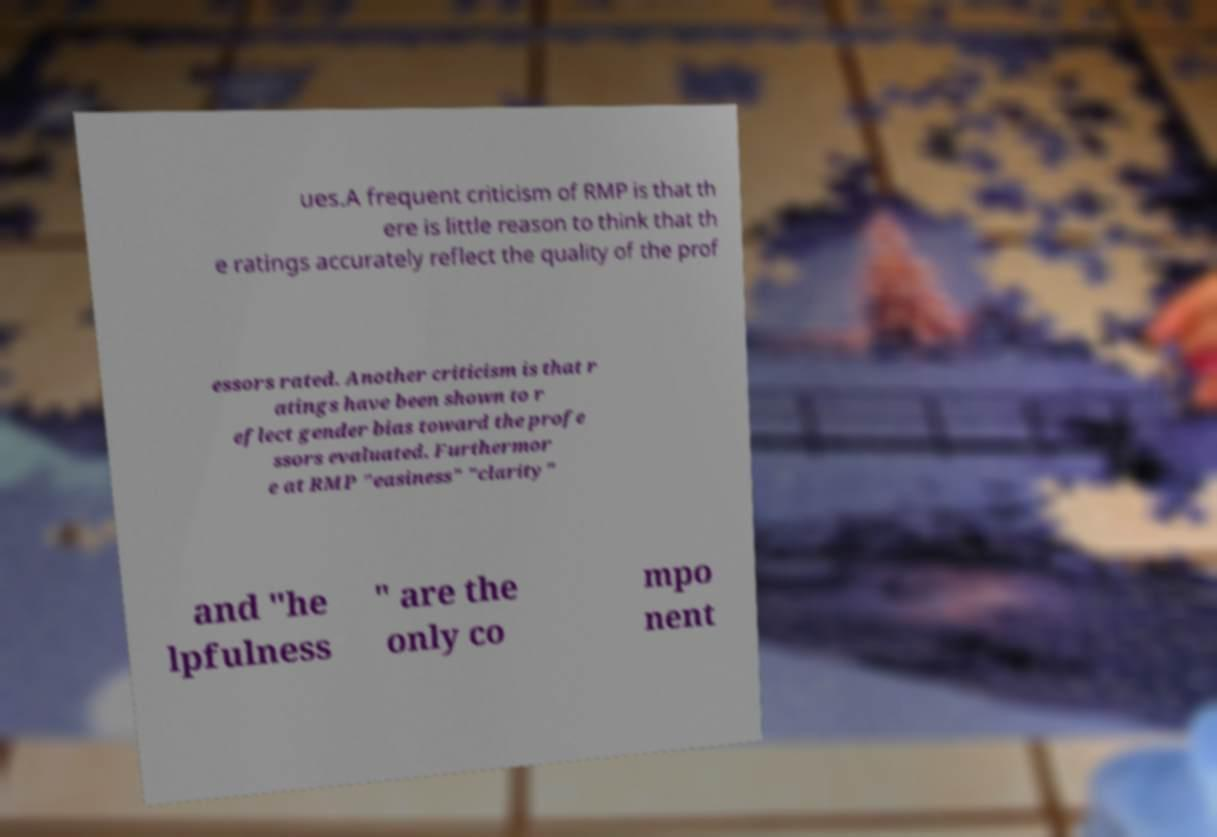Could you extract and type out the text from this image? ues.A frequent criticism of RMP is that th ere is little reason to think that th e ratings accurately reflect the quality of the prof essors rated. Another criticism is that r atings have been shown to r eflect gender bias toward the profe ssors evaluated. Furthermor e at RMP "easiness" "clarity" and "he lpfulness " are the only co mpo nent 